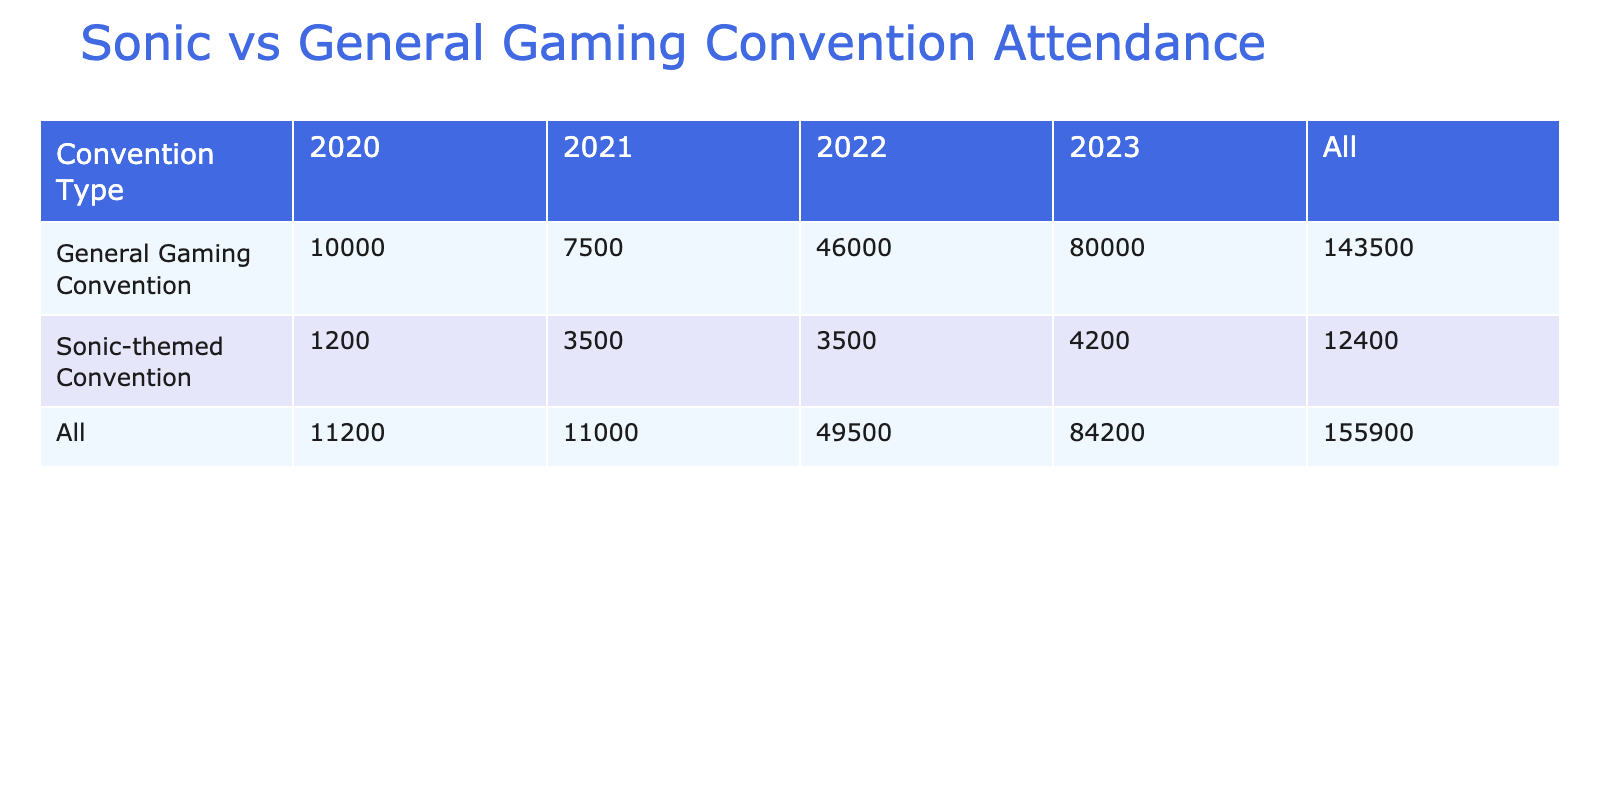What was the total attendance at Sonic-themed conventions in 2021? In 2021, the two Sonic-themed conventions were Sonic Boom and Sonic Fan Event. Their attendances were 2000 and 1500 respectively. Adding these numbers gives 2000 + 1500 = 3500.
Answer: 3500 What is the attendance difference between the highest and lowest attended Sonic-themed convention? The highest attended Sonic-themed convention is Sonic Expo in 2023, with an attendance of 4200, while the lowest is Sonic Celebration in 2020, with 1200 attendees. The difference is 4200 - 1200 = 3000.
Answer: 3000 Did any General Gaming Convention in 2023 have more than 20,000 attendees? In 2023, there were three General Gaming Conventions: Gamescom with 50000 attendees, BlizzCon with 30000 attendees. Both these conventions had more than 20000 attendees.
Answer: Yes What is the average attendance of General Gaming Conventions from 2021 to 2023? The attendances for General Gaming Conventions in those years are: 7500 (2021), 6000 (2022), and 50000 (2023). The average can be calculated: (7500 + 6000 + 50000) / 3 = 58500 / 3 = 19500.
Answer: 19500 How many Sonic-themed conventions had up to 3000 attendees? The Sonic-themed conventions with up to 3000 attendees are Sonic Boom (2000), Sonic Fan Event (1500), and Sonic Celebration (1200). This totals to three conventions.
Answer: 3 What was the total attendance for General Gaming Conventions in 2022? In 2022, the General Gaming Conventions were E3 (6000) and Tokyo Game Show (40000). Adding these gives 6000 + 40000 = 46000.
Answer: 46000 Is the total attendance at Sonic-themed conventions in 2022 greater than 5000? In 2022, there was one Sonic-themed convention, which is the Sonic the Hedgehog 30th Anniversary Festival with an attendance of 3500. Therefore, it is not greater than 5000.
Answer: No Which year had the highest attendance for General Gaming Conventions? Looking at the attendance figures, 2023 had the highest with Gamescom registering 50000 and BlizzCon 30000, totaling 80000. This is higher than 2021 and 2022.
Answer: 2023 